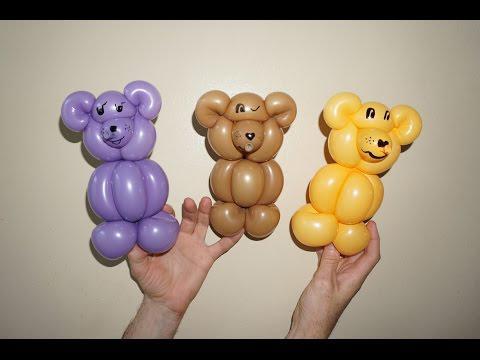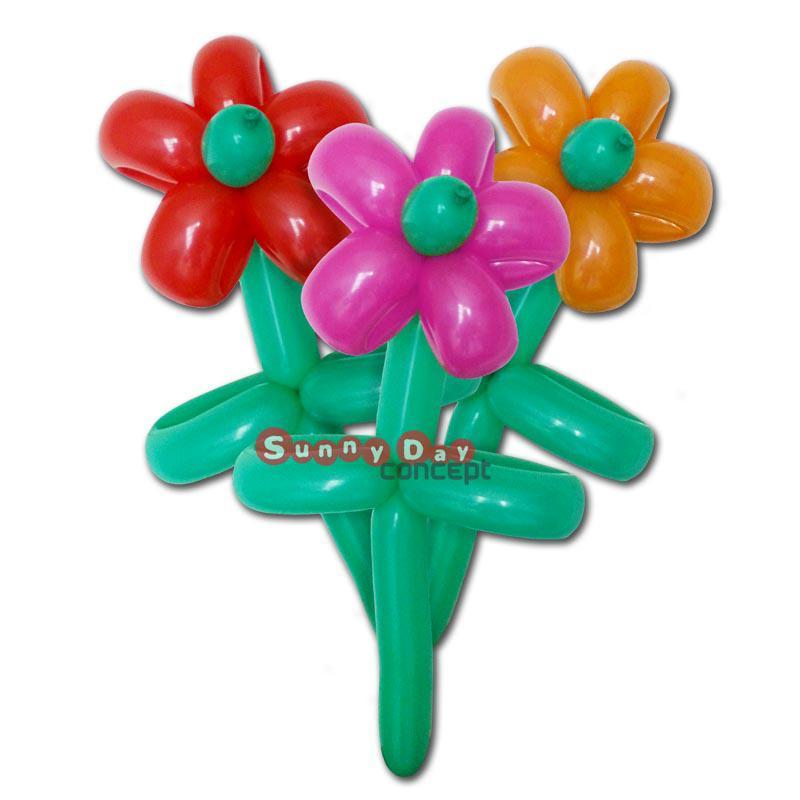The first image is the image on the left, the second image is the image on the right. For the images shown, is this caption "The right-hand image features a single balloon animal." true? Answer yes or no. No. 